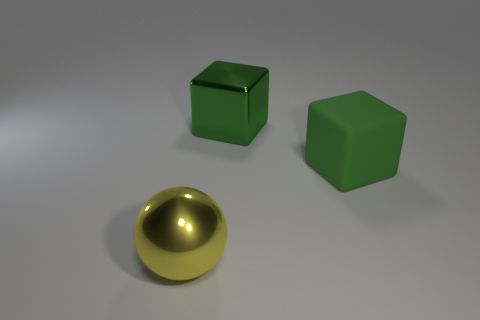Add 1 brown rubber things. How many objects exist? 4 Subtract all balls. How many objects are left? 2 Subtract 1 blocks. How many blocks are left? 1 Subtract all gray spheres. Subtract all blue cylinders. How many spheres are left? 1 Subtract all red balls. How many yellow blocks are left? 0 Subtract all small rubber spheres. Subtract all cubes. How many objects are left? 1 Add 2 big rubber cubes. How many big rubber cubes are left? 3 Add 1 big metallic spheres. How many big metallic spheres exist? 2 Subtract 0 cyan balls. How many objects are left? 3 